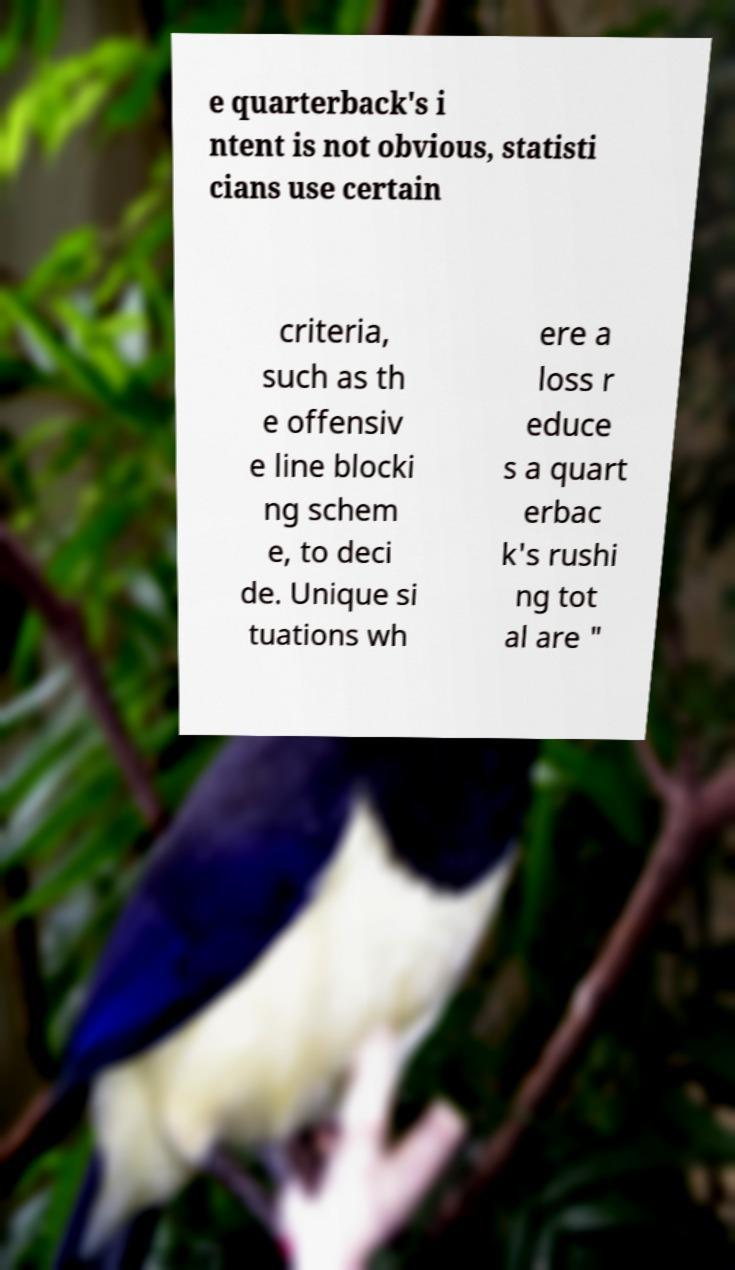Please read and relay the text visible in this image. What does it say? e quarterback's i ntent is not obvious, statisti cians use certain criteria, such as th e offensiv e line blocki ng schem e, to deci de. Unique si tuations wh ere a loss r educe s a quart erbac k's rushi ng tot al are " 